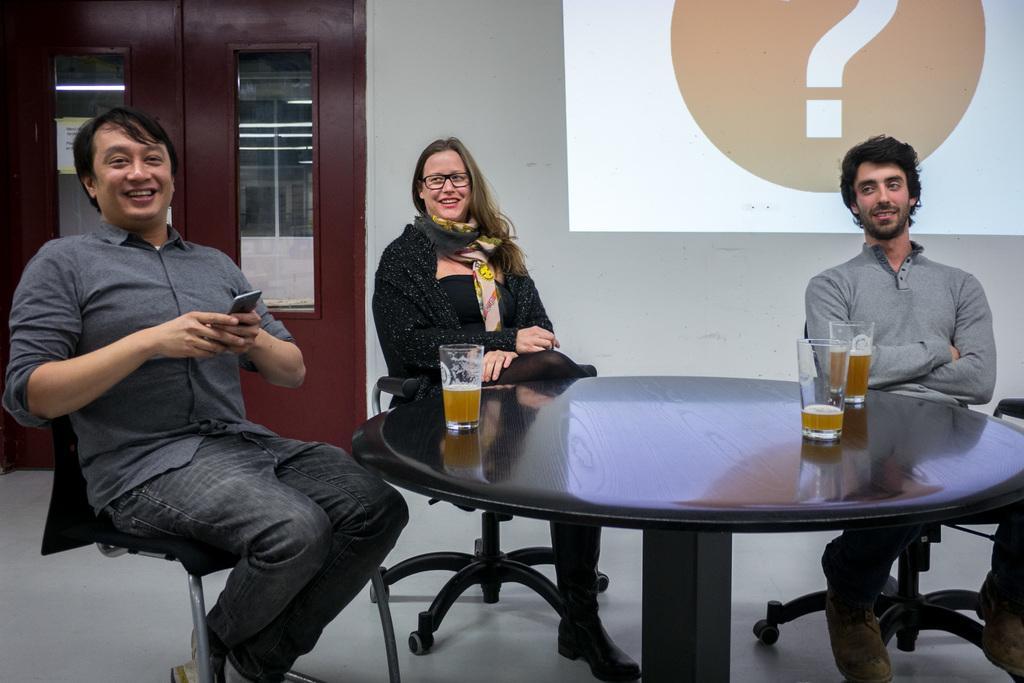In one or two sentences, can you explain what this image depicts? As we can see in the image there is a door, wall, screen,three people sitting on chairs and a table and glasses. 